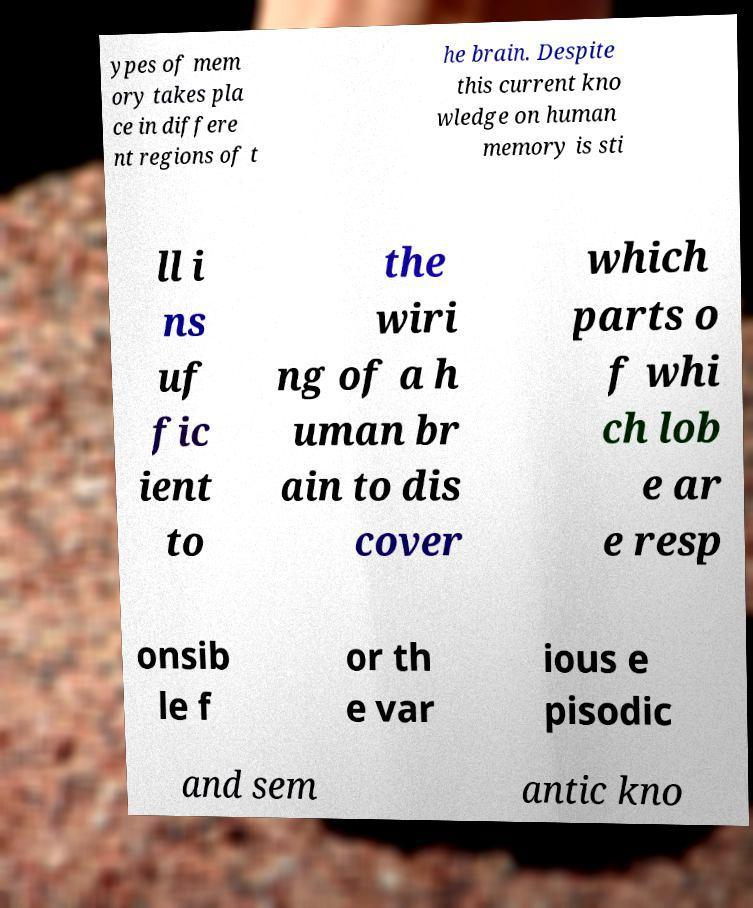Could you extract and type out the text from this image? ypes of mem ory takes pla ce in differe nt regions of t he brain. Despite this current kno wledge on human memory is sti ll i ns uf fic ient to the wiri ng of a h uman br ain to dis cover which parts o f whi ch lob e ar e resp onsib le f or th e var ious e pisodic and sem antic kno 